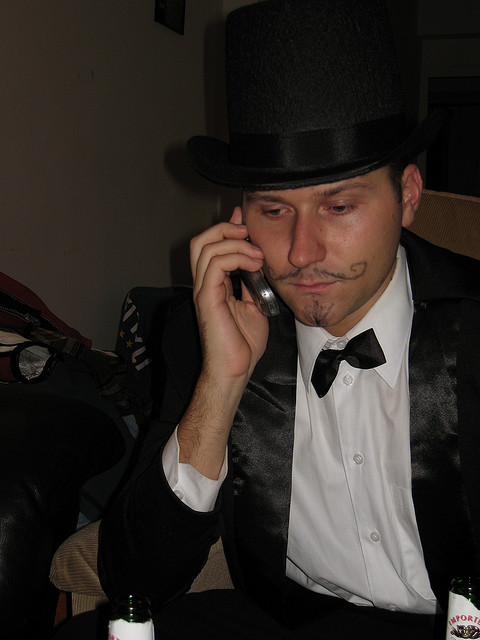Can you describe the man's attire? The man is dressed in a classic black-tie outfit, which consists of a black suit, a white dress shirt, and a black bow tie. He wears a top hat, adding a touch of vintage sophistication to his appearance. The mustache drawn on his face with what appears to be a marker suggests that his look may be part of a costume or meant for a themed event. 